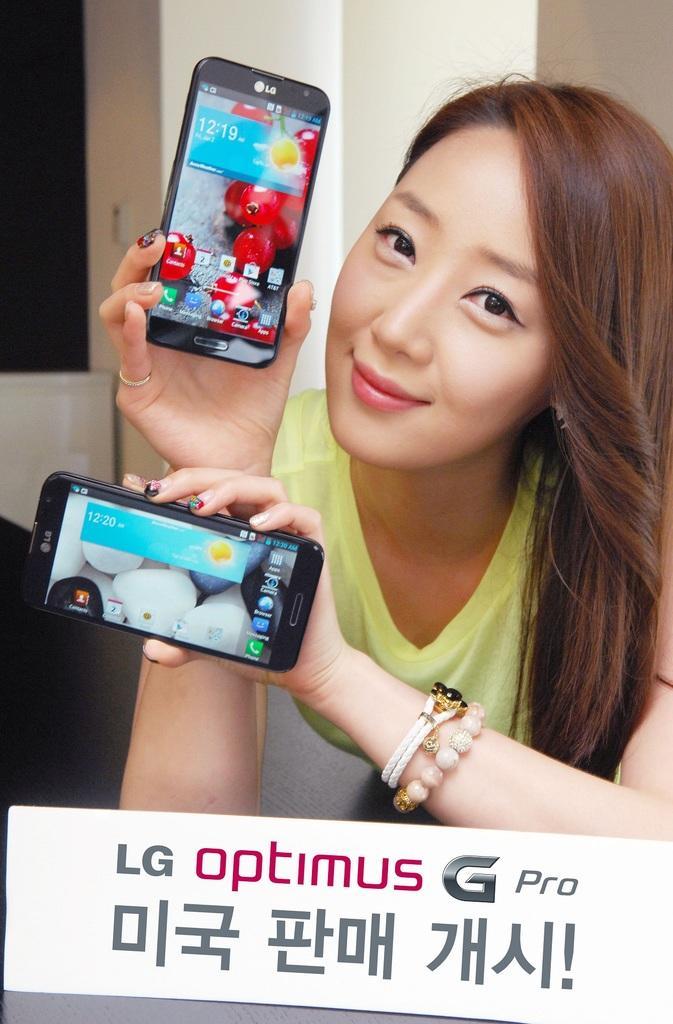How would you summarize this image in a sentence or two? In this image, a woman is standing and holding a mobile in her hand and having a smile on her face. In the bottom, a board is there of LG optimus. The background walls are white in color. And a window is visible at a left top. This image is taken inside a house. 